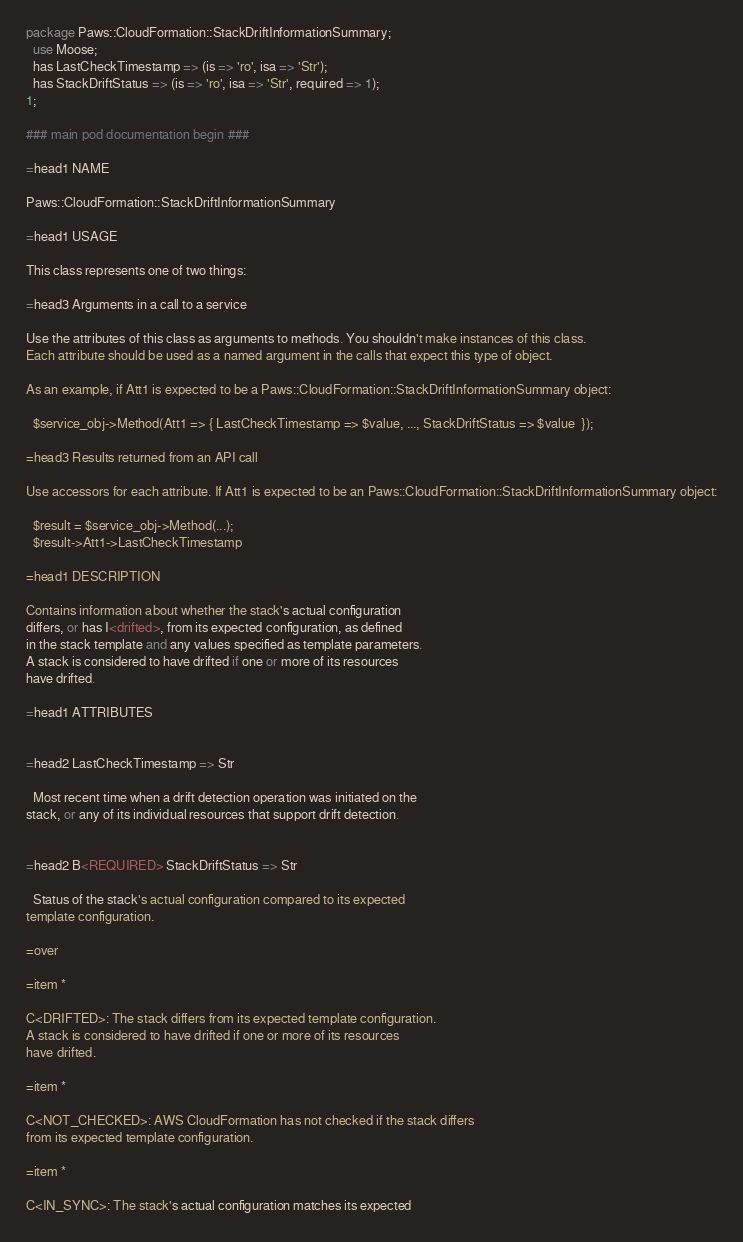<code> <loc_0><loc_0><loc_500><loc_500><_Perl_>package Paws::CloudFormation::StackDriftInformationSummary;
  use Moose;
  has LastCheckTimestamp => (is => 'ro', isa => 'Str');
  has StackDriftStatus => (is => 'ro', isa => 'Str', required => 1);
1;

### main pod documentation begin ###

=head1 NAME

Paws::CloudFormation::StackDriftInformationSummary

=head1 USAGE

This class represents one of two things:

=head3 Arguments in a call to a service

Use the attributes of this class as arguments to methods. You shouldn't make instances of this class. 
Each attribute should be used as a named argument in the calls that expect this type of object.

As an example, if Att1 is expected to be a Paws::CloudFormation::StackDriftInformationSummary object:

  $service_obj->Method(Att1 => { LastCheckTimestamp => $value, ..., StackDriftStatus => $value  });

=head3 Results returned from an API call

Use accessors for each attribute. If Att1 is expected to be an Paws::CloudFormation::StackDriftInformationSummary object:

  $result = $service_obj->Method(...);
  $result->Att1->LastCheckTimestamp

=head1 DESCRIPTION

Contains information about whether the stack's actual configuration
differs, or has I<drifted>, from its expected configuration, as defined
in the stack template and any values specified as template parameters.
A stack is considered to have drifted if one or more of its resources
have drifted.

=head1 ATTRIBUTES


=head2 LastCheckTimestamp => Str

  Most recent time when a drift detection operation was initiated on the
stack, or any of its individual resources that support drift detection.


=head2 B<REQUIRED> StackDriftStatus => Str

  Status of the stack's actual configuration compared to its expected
template configuration.

=over

=item *

C<DRIFTED>: The stack differs from its expected template configuration.
A stack is considered to have drifted if one or more of its resources
have drifted.

=item *

C<NOT_CHECKED>: AWS CloudFormation has not checked if the stack differs
from its expected template configuration.

=item *

C<IN_SYNC>: The stack's actual configuration matches its expected</code> 